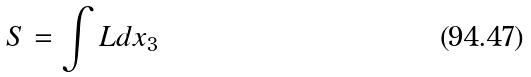Convert formula to latex. <formula><loc_0><loc_0><loc_500><loc_500>S = \int L d x _ { 3 }</formula> 